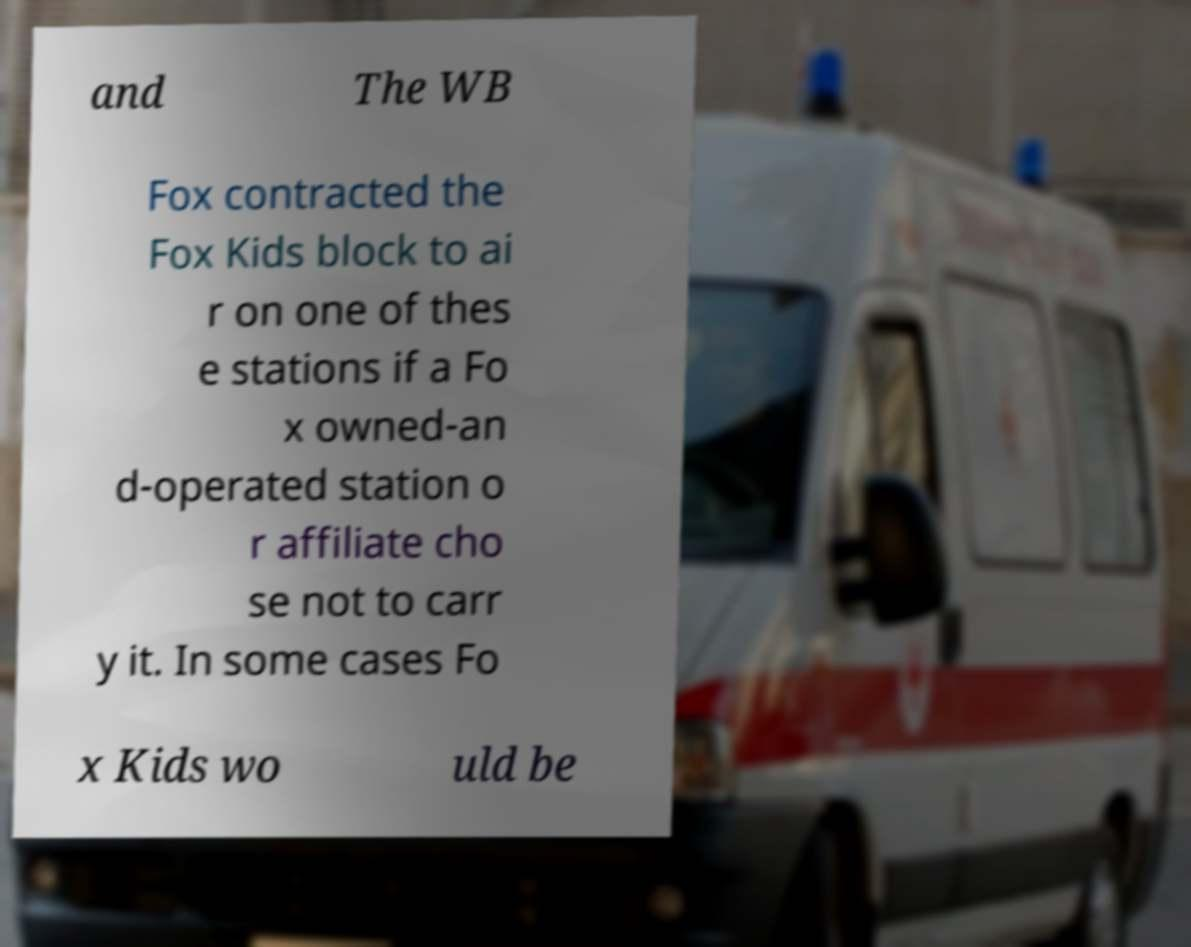Please identify and transcribe the text found in this image. and The WB Fox contracted the Fox Kids block to ai r on one of thes e stations if a Fo x owned-an d-operated station o r affiliate cho se not to carr y it. In some cases Fo x Kids wo uld be 